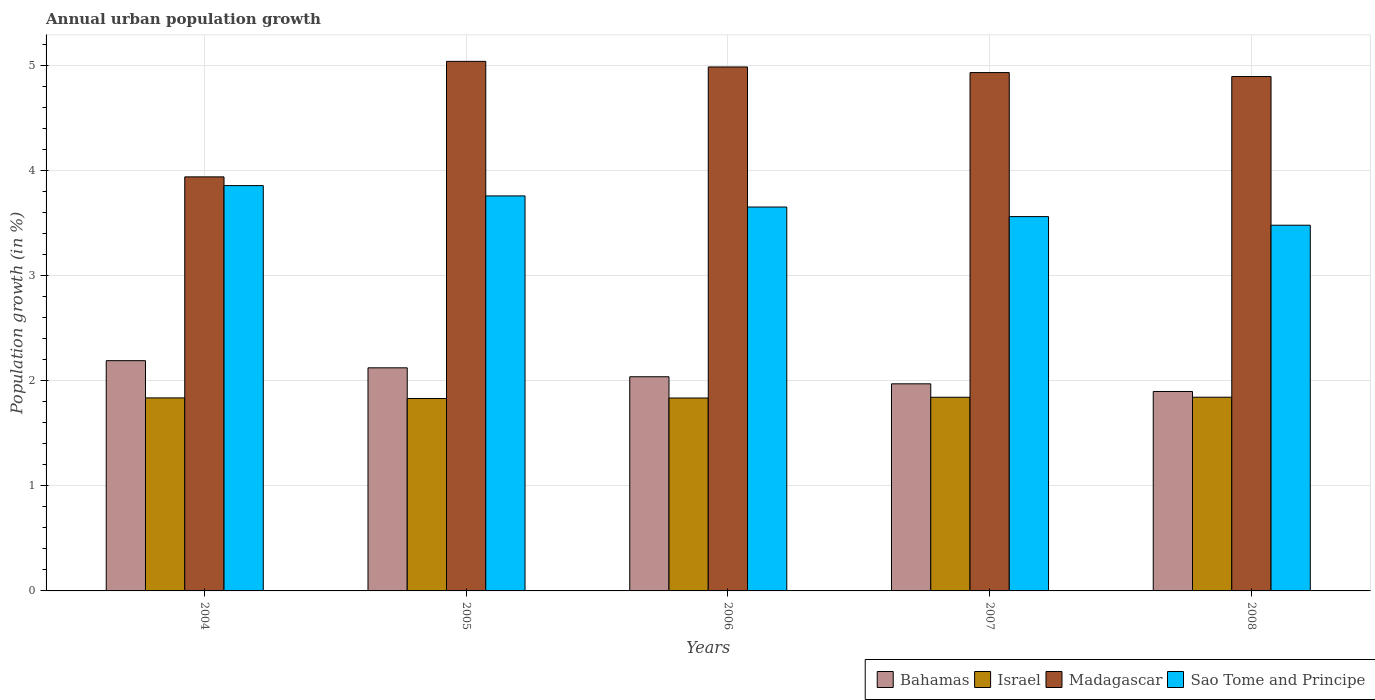How many groups of bars are there?
Your response must be concise. 5. Are the number of bars on each tick of the X-axis equal?
Your answer should be very brief. Yes. How many bars are there on the 4th tick from the left?
Provide a succinct answer. 4. What is the percentage of urban population growth in Sao Tome and Principe in 2008?
Ensure brevity in your answer.  3.48. Across all years, what is the maximum percentage of urban population growth in Sao Tome and Principe?
Offer a terse response. 3.86. Across all years, what is the minimum percentage of urban population growth in Madagascar?
Offer a very short reply. 3.94. In which year was the percentage of urban population growth in Israel maximum?
Your response must be concise. 2008. What is the total percentage of urban population growth in Israel in the graph?
Offer a very short reply. 9.19. What is the difference between the percentage of urban population growth in Madagascar in 2005 and that in 2007?
Offer a very short reply. 0.11. What is the difference between the percentage of urban population growth in Sao Tome and Principe in 2008 and the percentage of urban population growth in Israel in 2004?
Offer a terse response. 1.64. What is the average percentage of urban population growth in Bahamas per year?
Your response must be concise. 2.04. In the year 2004, what is the difference between the percentage of urban population growth in Madagascar and percentage of urban population growth in Israel?
Your response must be concise. 2.1. What is the ratio of the percentage of urban population growth in Israel in 2004 to that in 2008?
Make the answer very short. 1. Is the difference between the percentage of urban population growth in Madagascar in 2006 and 2008 greater than the difference between the percentage of urban population growth in Israel in 2006 and 2008?
Make the answer very short. Yes. What is the difference between the highest and the second highest percentage of urban population growth in Israel?
Give a very brief answer. 0. What is the difference between the highest and the lowest percentage of urban population growth in Israel?
Provide a succinct answer. 0.01. In how many years, is the percentage of urban population growth in Sao Tome and Principe greater than the average percentage of urban population growth in Sao Tome and Principe taken over all years?
Your answer should be very brief. 2. Is the sum of the percentage of urban population growth in Madagascar in 2005 and 2006 greater than the maximum percentage of urban population growth in Israel across all years?
Offer a very short reply. Yes. What does the 1st bar from the left in 2006 represents?
Give a very brief answer. Bahamas. What does the 4th bar from the right in 2006 represents?
Provide a short and direct response. Bahamas. How many years are there in the graph?
Give a very brief answer. 5. Are the values on the major ticks of Y-axis written in scientific E-notation?
Offer a terse response. No. Where does the legend appear in the graph?
Make the answer very short. Bottom right. How many legend labels are there?
Offer a very short reply. 4. How are the legend labels stacked?
Offer a very short reply. Horizontal. What is the title of the graph?
Provide a succinct answer. Annual urban population growth. Does "Kosovo" appear as one of the legend labels in the graph?
Give a very brief answer. No. What is the label or title of the Y-axis?
Provide a short and direct response. Population growth (in %). What is the Population growth (in %) in Bahamas in 2004?
Offer a very short reply. 2.19. What is the Population growth (in %) in Israel in 2004?
Provide a succinct answer. 1.84. What is the Population growth (in %) in Madagascar in 2004?
Ensure brevity in your answer.  3.94. What is the Population growth (in %) in Sao Tome and Principe in 2004?
Offer a very short reply. 3.86. What is the Population growth (in %) in Bahamas in 2005?
Offer a very short reply. 2.12. What is the Population growth (in %) of Israel in 2005?
Make the answer very short. 1.83. What is the Population growth (in %) of Madagascar in 2005?
Provide a succinct answer. 5.04. What is the Population growth (in %) of Sao Tome and Principe in 2005?
Provide a short and direct response. 3.76. What is the Population growth (in %) in Bahamas in 2006?
Your answer should be compact. 2.04. What is the Population growth (in %) of Israel in 2006?
Offer a terse response. 1.84. What is the Population growth (in %) of Madagascar in 2006?
Make the answer very short. 4.99. What is the Population growth (in %) in Sao Tome and Principe in 2006?
Your response must be concise. 3.65. What is the Population growth (in %) in Bahamas in 2007?
Your answer should be very brief. 1.97. What is the Population growth (in %) of Israel in 2007?
Give a very brief answer. 1.84. What is the Population growth (in %) of Madagascar in 2007?
Keep it short and to the point. 4.93. What is the Population growth (in %) in Sao Tome and Principe in 2007?
Keep it short and to the point. 3.56. What is the Population growth (in %) of Bahamas in 2008?
Offer a terse response. 1.9. What is the Population growth (in %) of Israel in 2008?
Offer a terse response. 1.84. What is the Population growth (in %) of Madagascar in 2008?
Provide a short and direct response. 4.89. What is the Population growth (in %) of Sao Tome and Principe in 2008?
Provide a short and direct response. 3.48. Across all years, what is the maximum Population growth (in %) of Bahamas?
Your response must be concise. 2.19. Across all years, what is the maximum Population growth (in %) of Israel?
Offer a terse response. 1.84. Across all years, what is the maximum Population growth (in %) of Madagascar?
Offer a terse response. 5.04. Across all years, what is the maximum Population growth (in %) of Sao Tome and Principe?
Offer a very short reply. 3.86. Across all years, what is the minimum Population growth (in %) of Bahamas?
Ensure brevity in your answer.  1.9. Across all years, what is the minimum Population growth (in %) in Israel?
Give a very brief answer. 1.83. Across all years, what is the minimum Population growth (in %) in Madagascar?
Your answer should be compact. 3.94. Across all years, what is the minimum Population growth (in %) of Sao Tome and Principe?
Your response must be concise. 3.48. What is the total Population growth (in %) in Bahamas in the graph?
Make the answer very short. 10.22. What is the total Population growth (in %) in Israel in the graph?
Offer a very short reply. 9.19. What is the total Population growth (in %) of Madagascar in the graph?
Ensure brevity in your answer.  23.79. What is the total Population growth (in %) in Sao Tome and Principe in the graph?
Ensure brevity in your answer.  18.31. What is the difference between the Population growth (in %) in Bahamas in 2004 and that in 2005?
Your answer should be compact. 0.07. What is the difference between the Population growth (in %) of Israel in 2004 and that in 2005?
Provide a short and direct response. 0.01. What is the difference between the Population growth (in %) of Madagascar in 2004 and that in 2005?
Ensure brevity in your answer.  -1.1. What is the difference between the Population growth (in %) in Sao Tome and Principe in 2004 and that in 2005?
Ensure brevity in your answer.  0.1. What is the difference between the Population growth (in %) of Bahamas in 2004 and that in 2006?
Ensure brevity in your answer.  0.15. What is the difference between the Population growth (in %) of Israel in 2004 and that in 2006?
Provide a succinct answer. 0. What is the difference between the Population growth (in %) in Madagascar in 2004 and that in 2006?
Provide a short and direct response. -1.05. What is the difference between the Population growth (in %) of Sao Tome and Principe in 2004 and that in 2006?
Make the answer very short. 0.2. What is the difference between the Population growth (in %) in Bahamas in 2004 and that in 2007?
Provide a succinct answer. 0.22. What is the difference between the Population growth (in %) of Israel in 2004 and that in 2007?
Ensure brevity in your answer.  -0.01. What is the difference between the Population growth (in %) of Madagascar in 2004 and that in 2007?
Ensure brevity in your answer.  -0.99. What is the difference between the Population growth (in %) of Sao Tome and Principe in 2004 and that in 2007?
Offer a very short reply. 0.29. What is the difference between the Population growth (in %) in Bahamas in 2004 and that in 2008?
Provide a short and direct response. 0.29. What is the difference between the Population growth (in %) in Israel in 2004 and that in 2008?
Your response must be concise. -0.01. What is the difference between the Population growth (in %) of Madagascar in 2004 and that in 2008?
Offer a terse response. -0.95. What is the difference between the Population growth (in %) of Sao Tome and Principe in 2004 and that in 2008?
Provide a short and direct response. 0.38. What is the difference between the Population growth (in %) of Bahamas in 2005 and that in 2006?
Keep it short and to the point. 0.09. What is the difference between the Population growth (in %) in Israel in 2005 and that in 2006?
Your answer should be very brief. -0. What is the difference between the Population growth (in %) of Madagascar in 2005 and that in 2006?
Your answer should be compact. 0.05. What is the difference between the Population growth (in %) in Sao Tome and Principe in 2005 and that in 2006?
Give a very brief answer. 0.11. What is the difference between the Population growth (in %) in Bahamas in 2005 and that in 2007?
Keep it short and to the point. 0.15. What is the difference between the Population growth (in %) of Israel in 2005 and that in 2007?
Your answer should be compact. -0.01. What is the difference between the Population growth (in %) of Madagascar in 2005 and that in 2007?
Give a very brief answer. 0.11. What is the difference between the Population growth (in %) in Sao Tome and Principe in 2005 and that in 2007?
Offer a very short reply. 0.2. What is the difference between the Population growth (in %) in Bahamas in 2005 and that in 2008?
Offer a terse response. 0.23. What is the difference between the Population growth (in %) in Israel in 2005 and that in 2008?
Offer a terse response. -0.01. What is the difference between the Population growth (in %) of Madagascar in 2005 and that in 2008?
Provide a succinct answer. 0.14. What is the difference between the Population growth (in %) of Sao Tome and Principe in 2005 and that in 2008?
Your answer should be very brief. 0.28. What is the difference between the Population growth (in %) of Bahamas in 2006 and that in 2007?
Keep it short and to the point. 0.07. What is the difference between the Population growth (in %) of Israel in 2006 and that in 2007?
Provide a succinct answer. -0.01. What is the difference between the Population growth (in %) in Madagascar in 2006 and that in 2007?
Offer a terse response. 0.05. What is the difference between the Population growth (in %) in Sao Tome and Principe in 2006 and that in 2007?
Make the answer very short. 0.09. What is the difference between the Population growth (in %) in Bahamas in 2006 and that in 2008?
Provide a short and direct response. 0.14. What is the difference between the Population growth (in %) in Israel in 2006 and that in 2008?
Offer a very short reply. -0.01. What is the difference between the Population growth (in %) of Madagascar in 2006 and that in 2008?
Offer a very short reply. 0.09. What is the difference between the Population growth (in %) in Sao Tome and Principe in 2006 and that in 2008?
Ensure brevity in your answer.  0.17. What is the difference between the Population growth (in %) of Bahamas in 2007 and that in 2008?
Provide a short and direct response. 0.07. What is the difference between the Population growth (in %) in Israel in 2007 and that in 2008?
Your response must be concise. -0. What is the difference between the Population growth (in %) in Madagascar in 2007 and that in 2008?
Ensure brevity in your answer.  0.04. What is the difference between the Population growth (in %) in Sao Tome and Principe in 2007 and that in 2008?
Provide a short and direct response. 0.08. What is the difference between the Population growth (in %) of Bahamas in 2004 and the Population growth (in %) of Israel in 2005?
Offer a terse response. 0.36. What is the difference between the Population growth (in %) of Bahamas in 2004 and the Population growth (in %) of Madagascar in 2005?
Give a very brief answer. -2.85. What is the difference between the Population growth (in %) in Bahamas in 2004 and the Population growth (in %) in Sao Tome and Principe in 2005?
Provide a short and direct response. -1.57. What is the difference between the Population growth (in %) of Israel in 2004 and the Population growth (in %) of Madagascar in 2005?
Offer a terse response. -3.2. What is the difference between the Population growth (in %) in Israel in 2004 and the Population growth (in %) in Sao Tome and Principe in 2005?
Provide a succinct answer. -1.92. What is the difference between the Population growth (in %) in Madagascar in 2004 and the Population growth (in %) in Sao Tome and Principe in 2005?
Your answer should be very brief. 0.18. What is the difference between the Population growth (in %) of Bahamas in 2004 and the Population growth (in %) of Israel in 2006?
Give a very brief answer. 0.36. What is the difference between the Population growth (in %) of Bahamas in 2004 and the Population growth (in %) of Madagascar in 2006?
Your answer should be compact. -2.79. What is the difference between the Population growth (in %) of Bahamas in 2004 and the Population growth (in %) of Sao Tome and Principe in 2006?
Provide a short and direct response. -1.46. What is the difference between the Population growth (in %) of Israel in 2004 and the Population growth (in %) of Madagascar in 2006?
Give a very brief answer. -3.15. What is the difference between the Population growth (in %) in Israel in 2004 and the Population growth (in %) in Sao Tome and Principe in 2006?
Provide a succinct answer. -1.82. What is the difference between the Population growth (in %) in Madagascar in 2004 and the Population growth (in %) in Sao Tome and Principe in 2006?
Give a very brief answer. 0.29. What is the difference between the Population growth (in %) of Bahamas in 2004 and the Population growth (in %) of Israel in 2007?
Your answer should be very brief. 0.35. What is the difference between the Population growth (in %) of Bahamas in 2004 and the Population growth (in %) of Madagascar in 2007?
Your answer should be compact. -2.74. What is the difference between the Population growth (in %) of Bahamas in 2004 and the Population growth (in %) of Sao Tome and Principe in 2007?
Keep it short and to the point. -1.37. What is the difference between the Population growth (in %) in Israel in 2004 and the Population growth (in %) in Madagascar in 2007?
Offer a very short reply. -3.1. What is the difference between the Population growth (in %) in Israel in 2004 and the Population growth (in %) in Sao Tome and Principe in 2007?
Ensure brevity in your answer.  -1.73. What is the difference between the Population growth (in %) in Madagascar in 2004 and the Population growth (in %) in Sao Tome and Principe in 2007?
Provide a succinct answer. 0.38. What is the difference between the Population growth (in %) in Bahamas in 2004 and the Population growth (in %) in Israel in 2008?
Your response must be concise. 0.35. What is the difference between the Population growth (in %) of Bahamas in 2004 and the Population growth (in %) of Madagascar in 2008?
Make the answer very short. -2.7. What is the difference between the Population growth (in %) in Bahamas in 2004 and the Population growth (in %) in Sao Tome and Principe in 2008?
Your answer should be very brief. -1.29. What is the difference between the Population growth (in %) in Israel in 2004 and the Population growth (in %) in Madagascar in 2008?
Offer a terse response. -3.06. What is the difference between the Population growth (in %) in Israel in 2004 and the Population growth (in %) in Sao Tome and Principe in 2008?
Make the answer very short. -1.64. What is the difference between the Population growth (in %) of Madagascar in 2004 and the Population growth (in %) of Sao Tome and Principe in 2008?
Make the answer very short. 0.46. What is the difference between the Population growth (in %) in Bahamas in 2005 and the Population growth (in %) in Israel in 2006?
Give a very brief answer. 0.29. What is the difference between the Population growth (in %) in Bahamas in 2005 and the Population growth (in %) in Madagascar in 2006?
Your answer should be compact. -2.86. What is the difference between the Population growth (in %) in Bahamas in 2005 and the Population growth (in %) in Sao Tome and Principe in 2006?
Your answer should be very brief. -1.53. What is the difference between the Population growth (in %) in Israel in 2005 and the Population growth (in %) in Madagascar in 2006?
Provide a succinct answer. -3.15. What is the difference between the Population growth (in %) of Israel in 2005 and the Population growth (in %) of Sao Tome and Principe in 2006?
Ensure brevity in your answer.  -1.82. What is the difference between the Population growth (in %) in Madagascar in 2005 and the Population growth (in %) in Sao Tome and Principe in 2006?
Offer a terse response. 1.39. What is the difference between the Population growth (in %) in Bahamas in 2005 and the Population growth (in %) in Israel in 2007?
Your response must be concise. 0.28. What is the difference between the Population growth (in %) in Bahamas in 2005 and the Population growth (in %) in Madagascar in 2007?
Offer a terse response. -2.81. What is the difference between the Population growth (in %) of Bahamas in 2005 and the Population growth (in %) of Sao Tome and Principe in 2007?
Provide a short and direct response. -1.44. What is the difference between the Population growth (in %) in Israel in 2005 and the Population growth (in %) in Madagascar in 2007?
Give a very brief answer. -3.1. What is the difference between the Population growth (in %) in Israel in 2005 and the Population growth (in %) in Sao Tome and Principe in 2007?
Give a very brief answer. -1.73. What is the difference between the Population growth (in %) in Madagascar in 2005 and the Population growth (in %) in Sao Tome and Principe in 2007?
Make the answer very short. 1.48. What is the difference between the Population growth (in %) of Bahamas in 2005 and the Population growth (in %) of Israel in 2008?
Give a very brief answer. 0.28. What is the difference between the Population growth (in %) in Bahamas in 2005 and the Population growth (in %) in Madagascar in 2008?
Offer a very short reply. -2.77. What is the difference between the Population growth (in %) in Bahamas in 2005 and the Population growth (in %) in Sao Tome and Principe in 2008?
Keep it short and to the point. -1.36. What is the difference between the Population growth (in %) in Israel in 2005 and the Population growth (in %) in Madagascar in 2008?
Provide a short and direct response. -3.06. What is the difference between the Population growth (in %) of Israel in 2005 and the Population growth (in %) of Sao Tome and Principe in 2008?
Offer a very short reply. -1.65. What is the difference between the Population growth (in %) in Madagascar in 2005 and the Population growth (in %) in Sao Tome and Principe in 2008?
Give a very brief answer. 1.56. What is the difference between the Population growth (in %) in Bahamas in 2006 and the Population growth (in %) in Israel in 2007?
Your answer should be very brief. 0.2. What is the difference between the Population growth (in %) in Bahamas in 2006 and the Population growth (in %) in Madagascar in 2007?
Ensure brevity in your answer.  -2.89. What is the difference between the Population growth (in %) in Bahamas in 2006 and the Population growth (in %) in Sao Tome and Principe in 2007?
Your answer should be compact. -1.52. What is the difference between the Population growth (in %) of Israel in 2006 and the Population growth (in %) of Madagascar in 2007?
Offer a terse response. -3.1. What is the difference between the Population growth (in %) of Israel in 2006 and the Population growth (in %) of Sao Tome and Principe in 2007?
Your answer should be compact. -1.73. What is the difference between the Population growth (in %) of Madagascar in 2006 and the Population growth (in %) of Sao Tome and Principe in 2007?
Your answer should be compact. 1.42. What is the difference between the Population growth (in %) of Bahamas in 2006 and the Population growth (in %) of Israel in 2008?
Make the answer very short. 0.19. What is the difference between the Population growth (in %) of Bahamas in 2006 and the Population growth (in %) of Madagascar in 2008?
Your answer should be compact. -2.86. What is the difference between the Population growth (in %) of Bahamas in 2006 and the Population growth (in %) of Sao Tome and Principe in 2008?
Keep it short and to the point. -1.44. What is the difference between the Population growth (in %) in Israel in 2006 and the Population growth (in %) in Madagascar in 2008?
Offer a very short reply. -3.06. What is the difference between the Population growth (in %) in Israel in 2006 and the Population growth (in %) in Sao Tome and Principe in 2008?
Your answer should be very brief. -1.64. What is the difference between the Population growth (in %) of Madagascar in 2006 and the Population growth (in %) of Sao Tome and Principe in 2008?
Your answer should be very brief. 1.51. What is the difference between the Population growth (in %) in Bahamas in 2007 and the Population growth (in %) in Israel in 2008?
Provide a short and direct response. 0.13. What is the difference between the Population growth (in %) in Bahamas in 2007 and the Population growth (in %) in Madagascar in 2008?
Your response must be concise. -2.92. What is the difference between the Population growth (in %) of Bahamas in 2007 and the Population growth (in %) of Sao Tome and Principe in 2008?
Offer a terse response. -1.51. What is the difference between the Population growth (in %) of Israel in 2007 and the Population growth (in %) of Madagascar in 2008?
Keep it short and to the point. -3.05. What is the difference between the Population growth (in %) of Israel in 2007 and the Population growth (in %) of Sao Tome and Principe in 2008?
Ensure brevity in your answer.  -1.64. What is the difference between the Population growth (in %) in Madagascar in 2007 and the Population growth (in %) in Sao Tome and Principe in 2008?
Keep it short and to the point. 1.45. What is the average Population growth (in %) of Bahamas per year?
Your answer should be very brief. 2.04. What is the average Population growth (in %) in Israel per year?
Provide a succinct answer. 1.84. What is the average Population growth (in %) of Madagascar per year?
Keep it short and to the point. 4.76. What is the average Population growth (in %) in Sao Tome and Principe per year?
Provide a short and direct response. 3.66. In the year 2004, what is the difference between the Population growth (in %) in Bahamas and Population growth (in %) in Israel?
Offer a very short reply. 0.35. In the year 2004, what is the difference between the Population growth (in %) of Bahamas and Population growth (in %) of Madagascar?
Your answer should be very brief. -1.75. In the year 2004, what is the difference between the Population growth (in %) of Bahamas and Population growth (in %) of Sao Tome and Principe?
Provide a short and direct response. -1.67. In the year 2004, what is the difference between the Population growth (in %) in Israel and Population growth (in %) in Madagascar?
Give a very brief answer. -2.1. In the year 2004, what is the difference between the Population growth (in %) of Israel and Population growth (in %) of Sao Tome and Principe?
Provide a succinct answer. -2.02. In the year 2004, what is the difference between the Population growth (in %) in Madagascar and Population growth (in %) in Sao Tome and Principe?
Your answer should be very brief. 0.08. In the year 2005, what is the difference between the Population growth (in %) of Bahamas and Population growth (in %) of Israel?
Give a very brief answer. 0.29. In the year 2005, what is the difference between the Population growth (in %) in Bahamas and Population growth (in %) in Madagascar?
Your response must be concise. -2.92. In the year 2005, what is the difference between the Population growth (in %) of Bahamas and Population growth (in %) of Sao Tome and Principe?
Offer a very short reply. -1.64. In the year 2005, what is the difference between the Population growth (in %) of Israel and Population growth (in %) of Madagascar?
Your answer should be compact. -3.21. In the year 2005, what is the difference between the Population growth (in %) in Israel and Population growth (in %) in Sao Tome and Principe?
Keep it short and to the point. -1.93. In the year 2005, what is the difference between the Population growth (in %) of Madagascar and Population growth (in %) of Sao Tome and Principe?
Give a very brief answer. 1.28. In the year 2006, what is the difference between the Population growth (in %) of Bahamas and Population growth (in %) of Israel?
Your answer should be compact. 0.2. In the year 2006, what is the difference between the Population growth (in %) in Bahamas and Population growth (in %) in Madagascar?
Provide a succinct answer. -2.95. In the year 2006, what is the difference between the Population growth (in %) of Bahamas and Population growth (in %) of Sao Tome and Principe?
Provide a short and direct response. -1.61. In the year 2006, what is the difference between the Population growth (in %) in Israel and Population growth (in %) in Madagascar?
Provide a short and direct response. -3.15. In the year 2006, what is the difference between the Population growth (in %) of Israel and Population growth (in %) of Sao Tome and Principe?
Provide a short and direct response. -1.82. In the year 2006, what is the difference between the Population growth (in %) of Madagascar and Population growth (in %) of Sao Tome and Principe?
Your answer should be compact. 1.33. In the year 2007, what is the difference between the Population growth (in %) in Bahamas and Population growth (in %) in Israel?
Keep it short and to the point. 0.13. In the year 2007, what is the difference between the Population growth (in %) of Bahamas and Population growth (in %) of Madagascar?
Make the answer very short. -2.96. In the year 2007, what is the difference between the Population growth (in %) of Bahamas and Population growth (in %) of Sao Tome and Principe?
Make the answer very short. -1.59. In the year 2007, what is the difference between the Population growth (in %) in Israel and Population growth (in %) in Madagascar?
Your answer should be very brief. -3.09. In the year 2007, what is the difference between the Population growth (in %) of Israel and Population growth (in %) of Sao Tome and Principe?
Provide a succinct answer. -1.72. In the year 2007, what is the difference between the Population growth (in %) of Madagascar and Population growth (in %) of Sao Tome and Principe?
Make the answer very short. 1.37. In the year 2008, what is the difference between the Population growth (in %) in Bahamas and Population growth (in %) in Israel?
Keep it short and to the point. 0.05. In the year 2008, what is the difference between the Population growth (in %) of Bahamas and Population growth (in %) of Madagascar?
Your response must be concise. -3. In the year 2008, what is the difference between the Population growth (in %) of Bahamas and Population growth (in %) of Sao Tome and Principe?
Your response must be concise. -1.58. In the year 2008, what is the difference between the Population growth (in %) in Israel and Population growth (in %) in Madagascar?
Your answer should be very brief. -3.05. In the year 2008, what is the difference between the Population growth (in %) in Israel and Population growth (in %) in Sao Tome and Principe?
Provide a succinct answer. -1.64. In the year 2008, what is the difference between the Population growth (in %) in Madagascar and Population growth (in %) in Sao Tome and Principe?
Offer a very short reply. 1.41. What is the ratio of the Population growth (in %) of Bahamas in 2004 to that in 2005?
Provide a succinct answer. 1.03. What is the ratio of the Population growth (in %) of Israel in 2004 to that in 2005?
Your response must be concise. 1. What is the ratio of the Population growth (in %) of Madagascar in 2004 to that in 2005?
Keep it short and to the point. 0.78. What is the ratio of the Population growth (in %) in Sao Tome and Principe in 2004 to that in 2005?
Your response must be concise. 1.03. What is the ratio of the Population growth (in %) of Bahamas in 2004 to that in 2006?
Your answer should be compact. 1.08. What is the ratio of the Population growth (in %) of Israel in 2004 to that in 2006?
Give a very brief answer. 1. What is the ratio of the Population growth (in %) of Madagascar in 2004 to that in 2006?
Your answer should be very brief. 0.79. What is the ratio of the Population growth (in %) in Sao Tome and Principe in 2004 to that in 2006?
Provide a succinct answer. 1.06. What is the ratio of the Population growth (in %) in Bahamas in 2004 to that in 2007?
Your answer should be compact. 1.11. What is the ratio of the Population growth (in %) in Israel in 2004 to that in 2007?
Offer a terse response. 1. What is the ratio of the Population growth (in %) of Madagascar in 2004 to that in 2007?
Your answer should be compact. 0.8. What is the ratio of the Population growth (in %) in Sao Tome and Principe in 2004 to that in 2007?
Provide a succinct answer. 1.08. What is the ratio of the Population growth (in %) in Bahamas in 2004 to that in 2008?
Offer a very short reply. 1.15. What is the ratio of the Population growth (in %) in Israel in 2004 to that in 2008?
Provide a short and direct response. 1. What is the ratio of the Population growth (in %) in Madagascar in 2004 to that in 2008?
Ensure brevity in your answer.  0.8. What is the ratio of the Population growth (in %) in Sao Tome and Principe in 2004 to that in 2008?
Your answer should be compact. 1.11. What is the ratio of the Population growth (in %) of Bahamas in 2005 to that in 2006?
Provide a succinct answer. 1.04. What is the ratio of the Population growth (in %) of Madagascar in 2005 to that in 2006?
Provide a short and direct response. 1.01. What is the ratio of the Population growth (in %) of Sao Tome and Principe in 2005 to that in 2006?
Make the answer very short. 1.03. What is the ratio of the Population growth (in %) of Bahamas in 2005 to that in 2007?
Keep it short and to the point. 1.08. What is the ratio of the Population growth (in %) in Madagascar in 2005 to that in 2007?
Ensure brevity in your answer.  1.02. What is the ratio of the Population growth (in %) in Sao Tome and Principe in 2005 to that in 2007?
Offer a terse response. 1.06. What is the ratio of the Population growth (in %) of Bahamas in 2005 to that in 2008?
Offer a very short reply. 1.12. What is the ratio of the Population growth (in %) of Israel in 2005 to that in 2008?
Provide a short and direct response. 0.99. What is the ratio of the Population growth (in %) of Madagascar in 2005 to that in 2008?
Your response must be concise. 1.03. What is the ratio of the Population growth (in %) in Sao Tome and Principe in 2005 to that in 2008?
Ensure brevity in your answer.  1.08. What is the ratio of the Population growth (in %) of Bahamas in 2006 to that in 2007?
Offer a very short reply. 1.03. What is the ratio of the Population growth (in %) of Madagascar in 2006 to that in 2007?
Make the answer very short. 1.01. What is the ratio of the Population growth (in %) in Sao Tome and Principe in 2006 to that in 2007?
Keep it short and to the point. 1.03. What is the ratio of the Population growth (in %) of Bahamas in 2006 to that in 2008?
Give a very brief answer. 1.07. What is the ratio of the Population growth (in %) in Madagascar in 2006 to that in 2008?
Provide a succinct answer. 1.02. What is the ratio of the Population growth (in %) of Sao Tome and Principe in 2006 to that in 2008?
Your answer should be very brief. 1.05. What is the ratio of the Population growth (in %) in Bahamas in 2007 to that in 2008?
Keep it short and to the point. 1.04. What is the ratio of the Population growth (in %) in Israel in 2007 to that in 2008?
Keep it short and to the point. 1. What is the ratio of the Population growth (in %) of Madagascar in 2007 to that in 2008?
Your answer should be very brief. 1.01. What is the ratio of the Population growth (in %) of Sao Tome and Principe in 2007 to that in 2008?
Keep it short and to the point. 1.02. What is the difference between the highest and the second highest Population growth (in %) in Bahamas?
Your response must be concise. 0.07. What is the difference between the highest and the second highest Population growth (in %) in Israel?
Offer a terse response. 0. What is the difference between the highest and the second highest Population growth (in %) of Madagascar?
Your response must be concise. 0.05. What is the difference between the highest and the second highest Population growth (in %) in Sao Tome and Principe?
Ensure brevity in your answer.  0.1. What is the difference between the highest and the lowest Population growth (in %) of Bahamas?
Provide a short and direct response. 0.29. What is the difference between the highest and the lowest Population growth (in %) in Israel?
Keep it short and to the point. 0.01. What is the difference between the highest and the lowest Population growth (in %) in Madagascar?
Ensure brevity in your answer.  1.1. What is the difference between the highest and the lowest Population growth (in %) of Sao Tome and Principe?
Give a very brief answer. 0.38. 